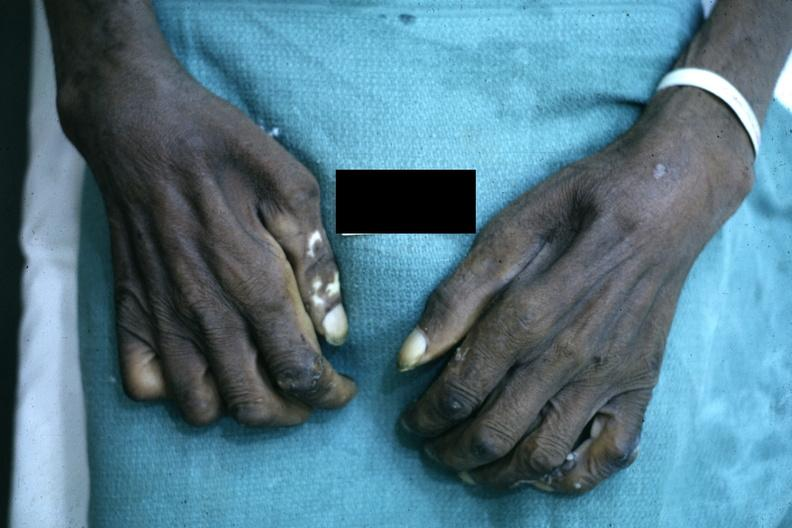what does this image show?
Answer the question using a single word or phrase. Close-up excellent example of interosseous muscle atrophy said to be due to syringomyelus 